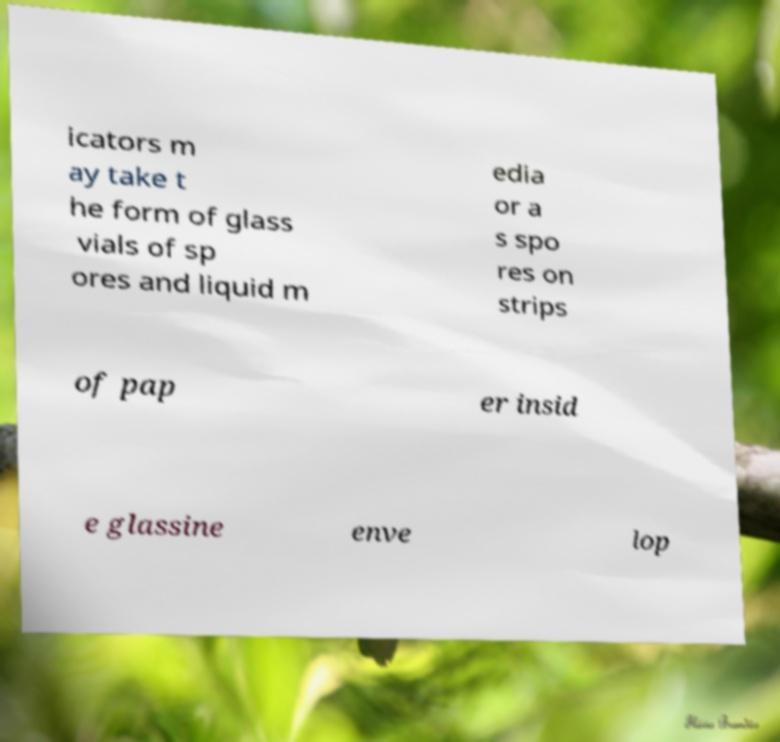Can you accurately transcribe the text from the provided image for me? icators m ay take t he form of glass vials of sp ores and liquid m edia or a s spo res on strips of pap er insid e glassine enve lop 